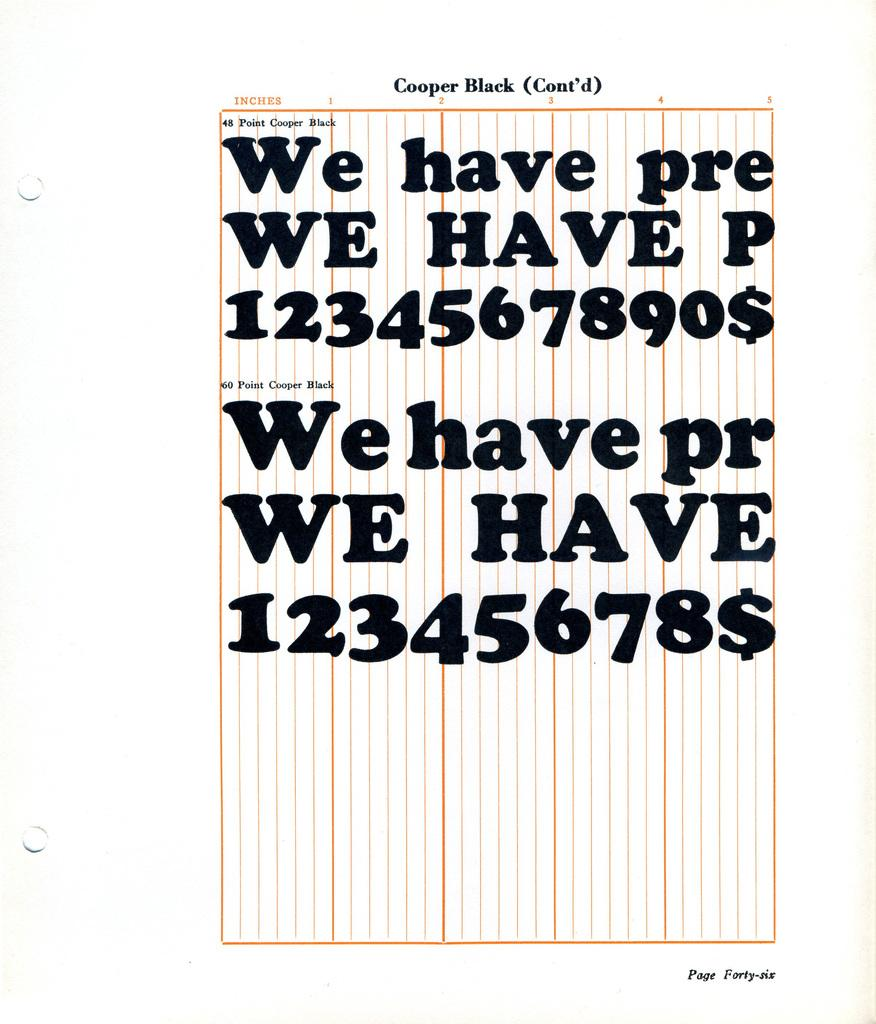Provide a one-sentence caption for the provided image. Page from a book that is titled "Cooper Black". 